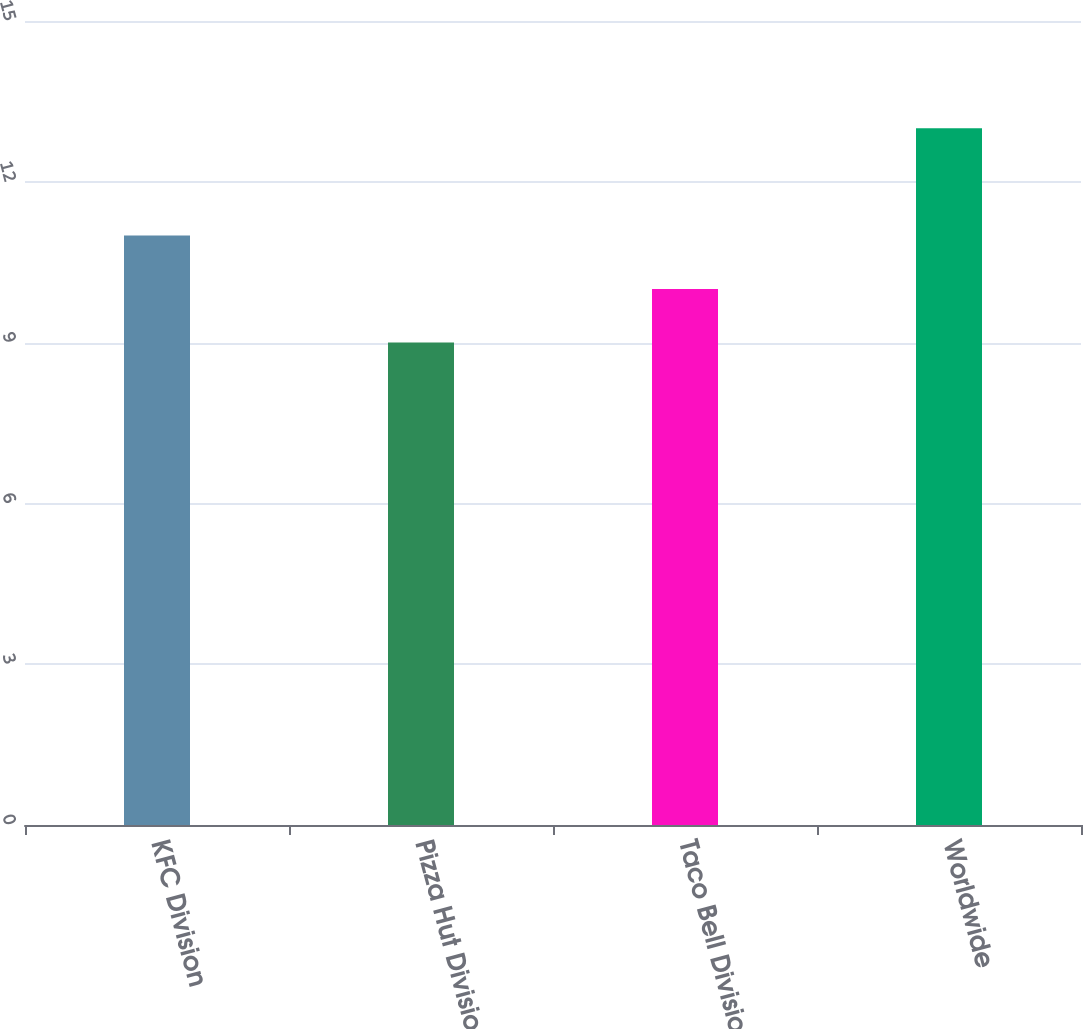Convert chart. <chart><loc_0><loc_0><loc_500><loc_500><bar_chart><fcel>KFC Division<fcel>Pizza Hut Division<fcel>Taco Bell Division<fcel>Worldwide<nl><fcel>11<fcel>9<fcel>10<fcel>13<nl></chart> 